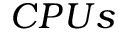Convert formula to latex. <formula><loc_0><loc_0><loc_500><loc_500>C P U s</formula> 